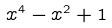<formula> <loc_0><loc_0><loc_500><loc_500>x ^ { 4 } - x ^ { 2 } + 1</formula> 